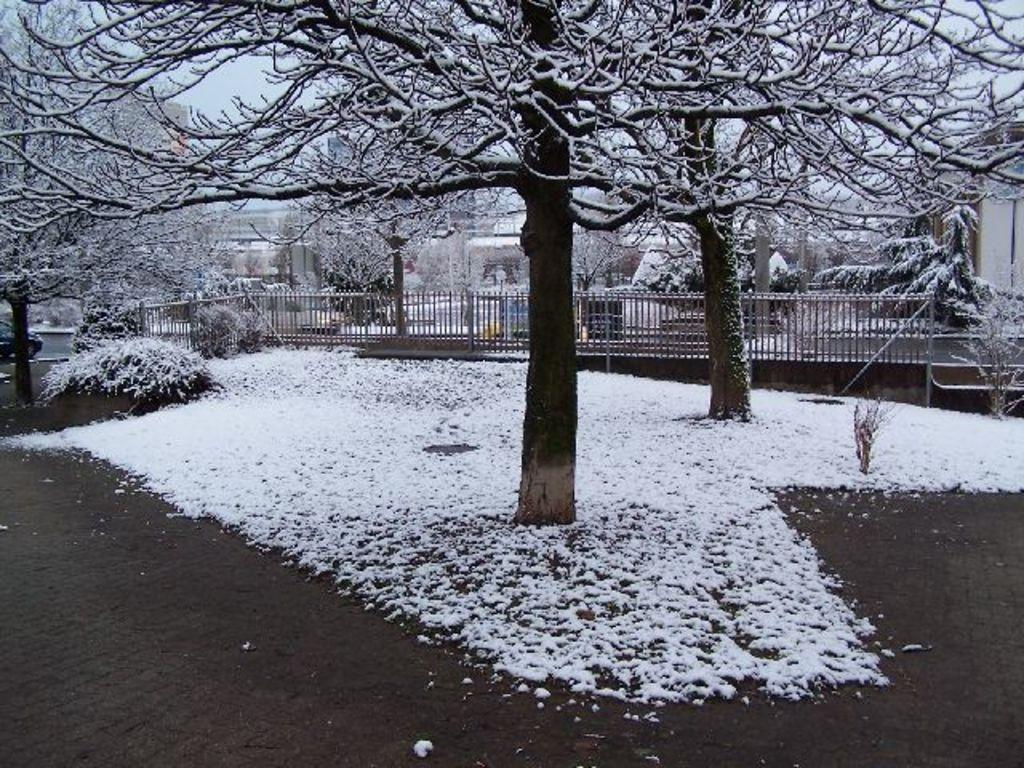What is the predominant weather condition in the image? There is snow in the image, indicating a cold and wintry condition. What type of natural elements can be seen in the image? There are trees and plants visible in the image. What architectural feature is present in the image? There is a railing in the image. What can be seen in the background of the image? There are buildings and the sky visible in the background of the image. Can you see any flames coming from the trees in the image? No, there are no flames present in the image; it features snow, trees, and plants. Are there any people involved in a fight in the image? No, there are no people or fights depicted in the image. 